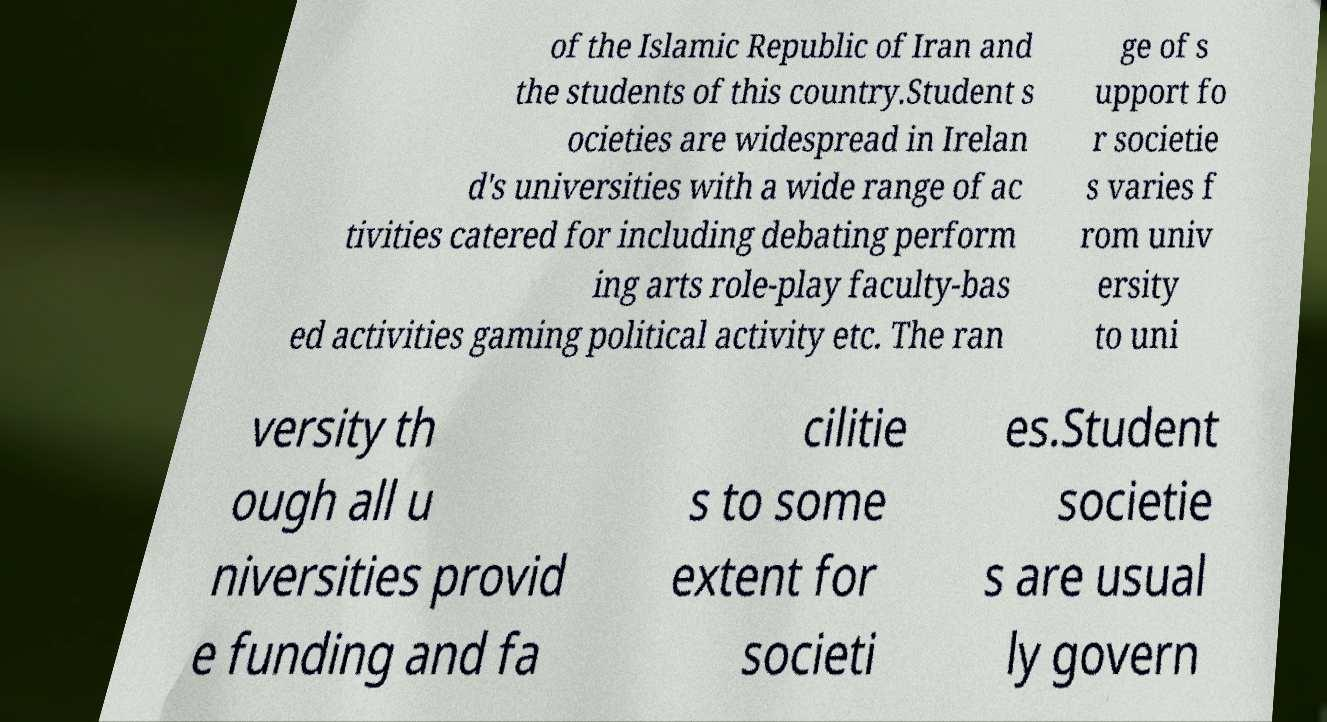Can you accurately transcribe the text from the provided image for me? of the Islamic Republic of Iran and the students of this country.Student s ocieties are widespread in Irelan d's universities with a wide range of ac tivities catered for including debating perform ing arts role-play faculty-bas ed activities gaming political activity etc. The ran ge of s upport fo r societie s varies f rom univ ersity to uni versity th ough all u niversities provid e funding and fa cilitie s to some extent for societi es.Student societie s are usual ly govern 